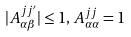<formula> <loc_0><loc_0><loc_500><loc_500>| A ^ { j j ^ { \prime } } _ { \alpha \beta } | \leq 1 , \, A ^ { j j } _ { \alpha \alpha } = 1</formula> 